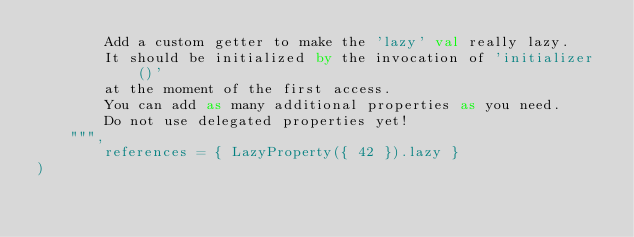<code> <loc_0><loc_0><loc_500><loc_500><_Kotlin_>        Add a custom getter to make the 'lazy' val really lazy.
        It should be initialized by the invocation of 'initializer()'
        at the moment of the first access.
        You can add as many additional properties as you need.
        Do not use delegated properties yet!
    """,
        references = { LazyProperty({ 42 }).lazy }
)
</code> 